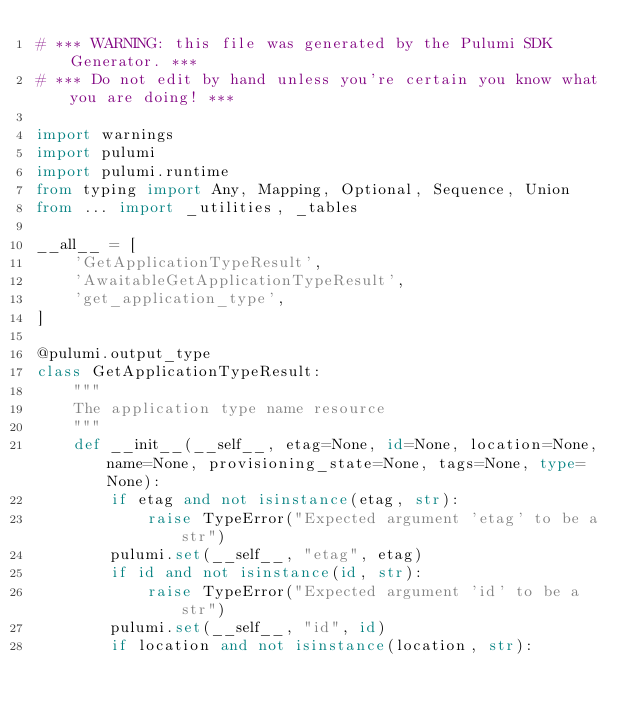Convert code to text. <code><loc_0><loc_0><loc_500><loc_500><_Python_># *** WARNING: this file was generated by the Pulumi SDK Generator. ***
# *** Do not edit by hand unless you're certain you know what you are doing! ***

import warnings
import pulumi
import pulumi.runtime
from typing import Any, Mapping, Optional, Sequence, Union
from ... import _utilities, _tables

__all__ = [
    'GetApplicationTypeResult',
    'AwaitableGetApplicationTypeResult',
    'get_application_type',
]

@pulumi.output_type
class GetApplicationTypeResult:
    """
    The application type name resource
    """
    def __init__(__self__, etag=None, id=None, location=None, name=None, provisioning_state=None, tags=None, type=None):
        if etag and not isinstance(etag, str):
            raise TypeError("Expected argument 'etag' to be a str")
        pulumi.set(__self__, "etag", etag)
        if id and not isinstance(id, str):
            raise TypeError("Expected argument 'id' to be a str")
        pulumi.set(__self__, "id", id)
        if location and not isinstance(location, str):</code> 